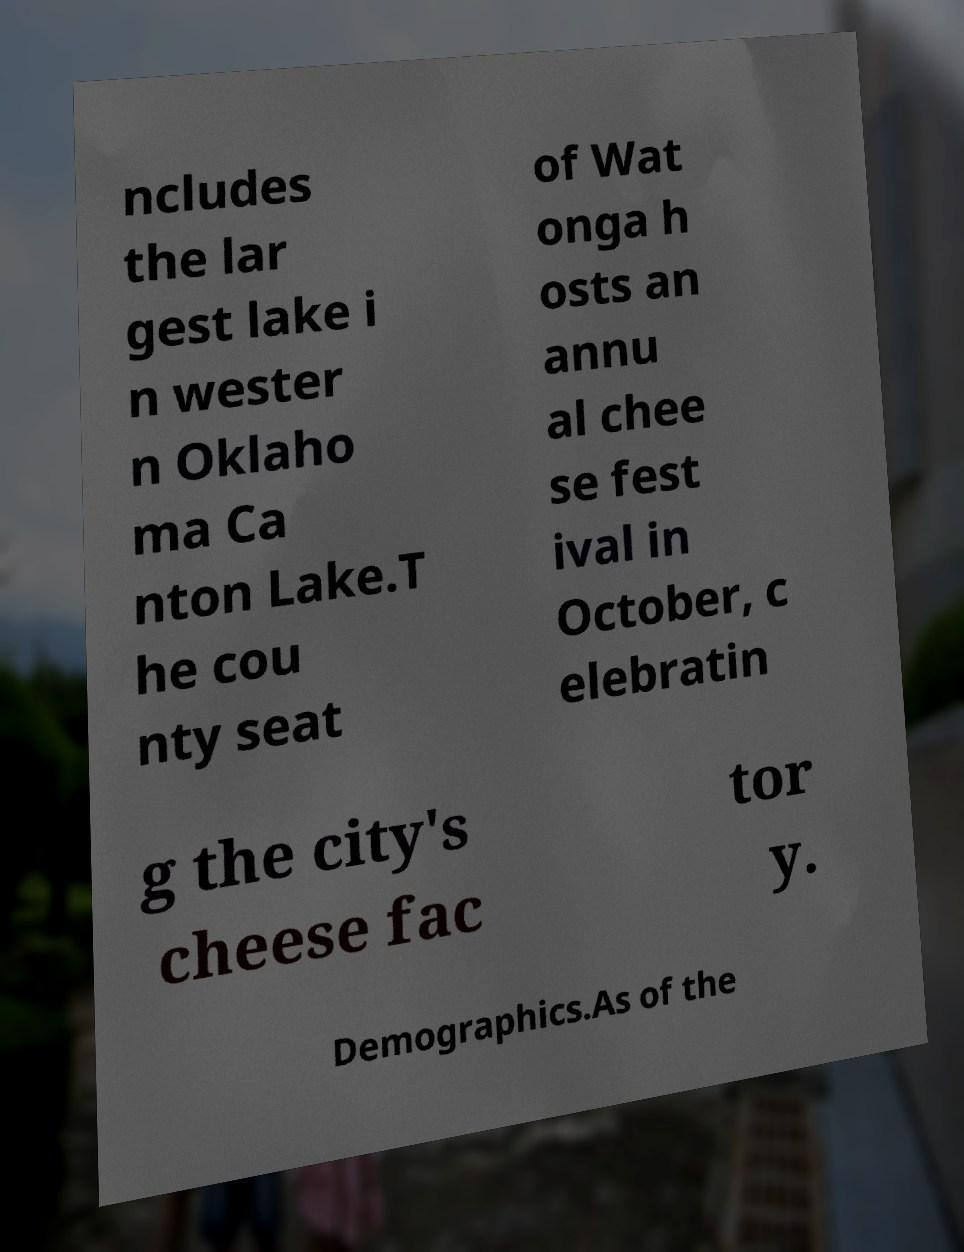Could you extract and type out the text from this image? ncludes the lar gest lake i n wester n Oklaho ma Ca nton Lake.T he cou nty seat of Wat onga h osts an annu al chee se fest ival in October, c elebratin g the city's cheese fac tor y. Demographics.As of the 